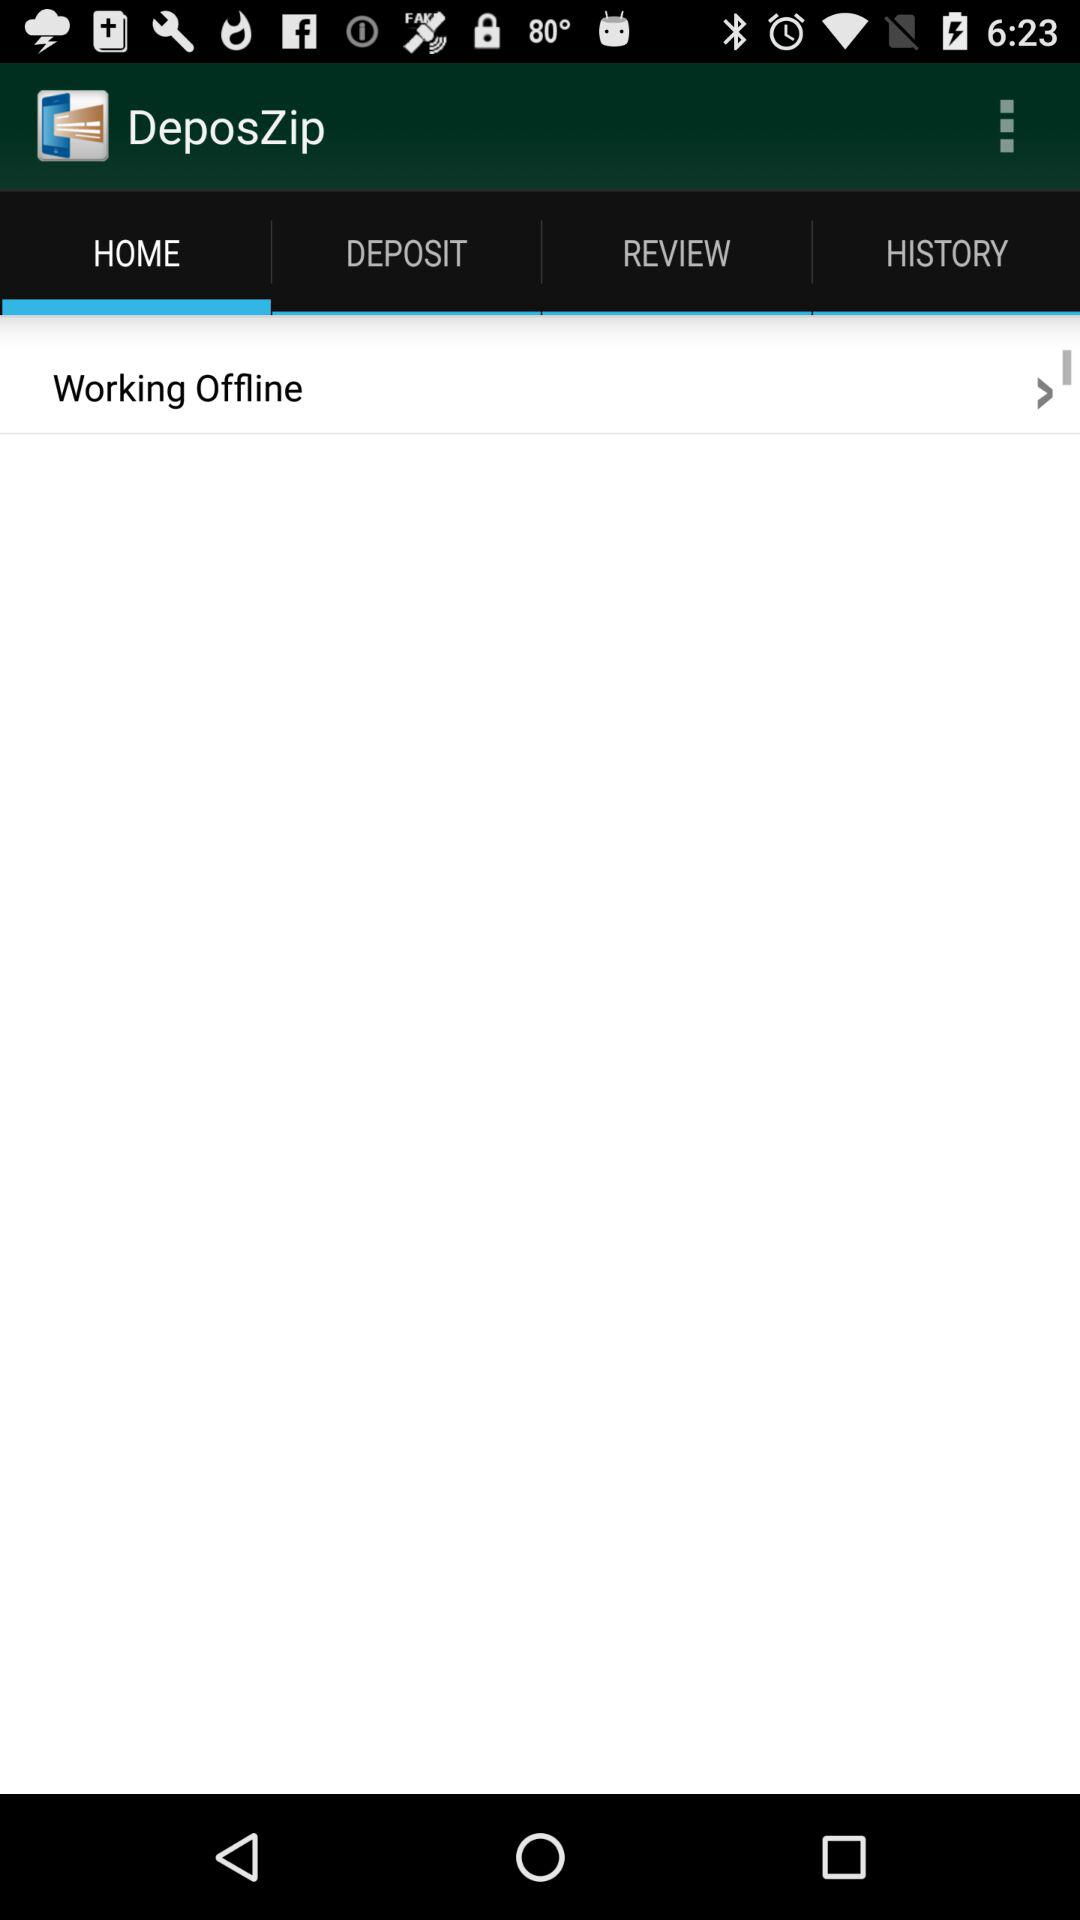What is the application name? The application name is "DeposZip Mobile". 